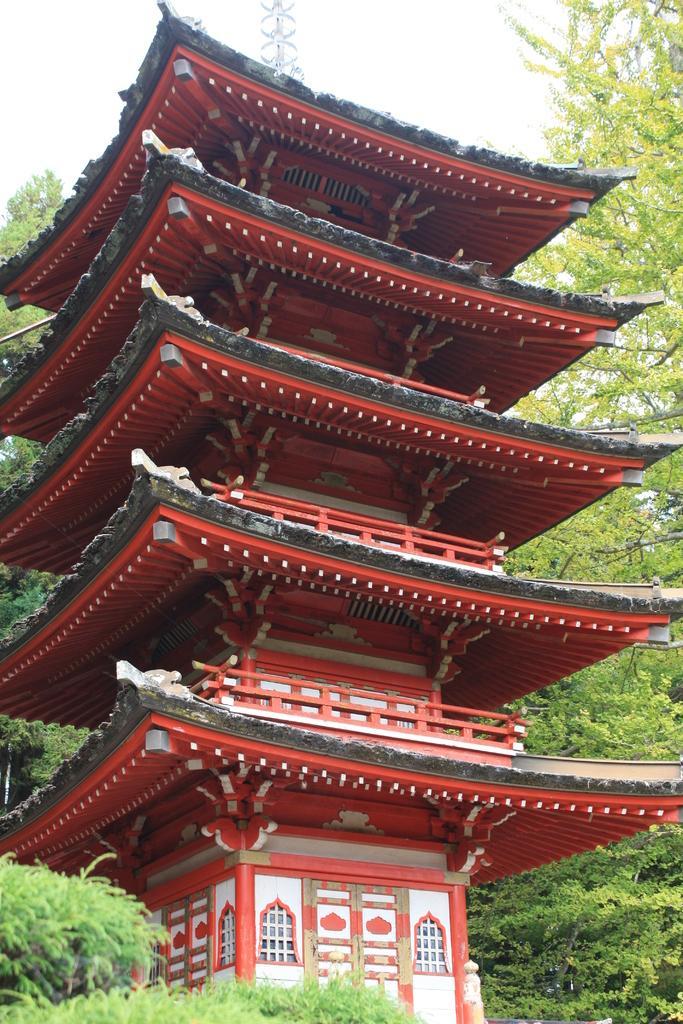Please provide a concise description of this image. In this image I can see the building, windows, trees and the sky. 